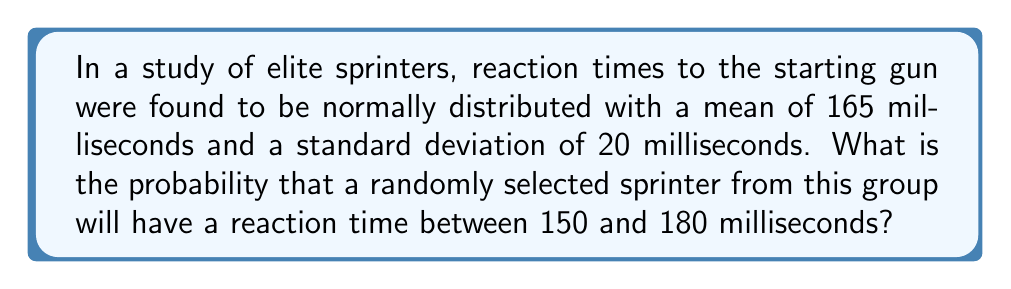Show me your answer to this math problem. To solve this problem, we'll use the properties of the normal distribution and the z-score formula. Here's a step-by-step approach:

1) First, we need to calculate the z-scores for both 150 ms and 180 ms.
   The z-score formula is: $z = \frac{x - \mu}{\sigma}$
   Where $x$ is the value, $\mu$ is the mean, and $\sigma$ is the standard deviation.

2) For 150 ms:
   $z_1 = \frac{150 - 165}{20} = -0.75$

3) For 180 ms:
   $z_2 = \frac{180 - 165}{20} = 0.75$

4) Now, we need to find the area under the standard normal curve between these two z-scores.

5) Using a standard normal distribution table or calculator:
   $P(z \leq 0.75) = 0.7734$
   $P(z \leq -0.75) = 0.2266$

6) The probability we're looking for is the difference between these two:
   $P(-0.75 \leq z \leq 0.75) = 0.7734 - 0.2266 = 0.5468$

7) Therefore, the probability that a randomly selected sprinter will have a reaction time between 150 and 180 milliseconds is approximately 0.5468 or 54.68%.
Answer: 0.5468 